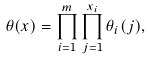Convert formula to latex. <formula><loc_0><loc_0><loc_500><loc_500>\theta ( x ) = \prod _ { i = 1 } ^ { m } \prod _ { j = 1 } ^ { x _ { i } } \theta _ { i } ( j ) ,</formula> 